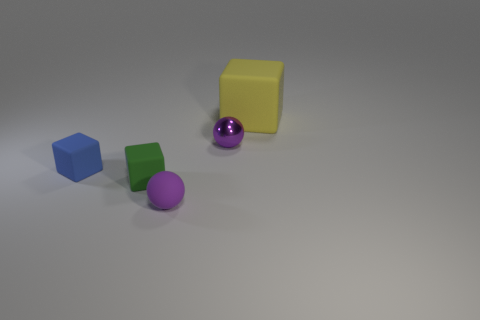Add 4 tiny purple matte things. How many objects exist? 9 Subtract all balls. How many objects are left? 3 Add 2 big blue matte objects. How many big blue matte objects exist? 2 Subtract 0 gray cylinders. How many objects are left? 5 Subtract all green matte cubes. Subtract all tiny blue rubber spheres. How many objects are left? 4 Add 1 tiny balls. How many tiny balls are left? 3 